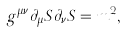<formula> <loc_0><loc_0><loc_500><loc_500>g ^ { \mu \nu } \partial _ { \mu } S \partial _ { \nu } S = m ^ { 2 } ,</formula> 